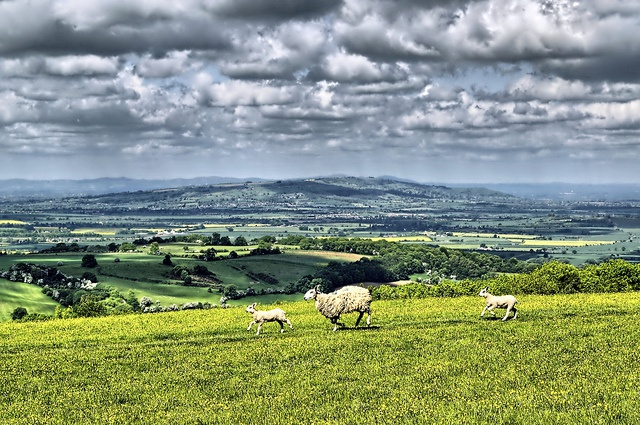Describe the objects in this image and their specific colors. I can see sheep in gray, beige, khaki, black, and tan tones, sheep in gray, beige, khaki, black, and darkgreen tones, and sheep in gray, beige, khaki, black, and tan tones in this image. 